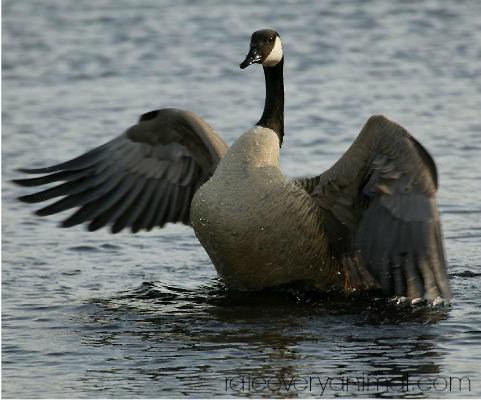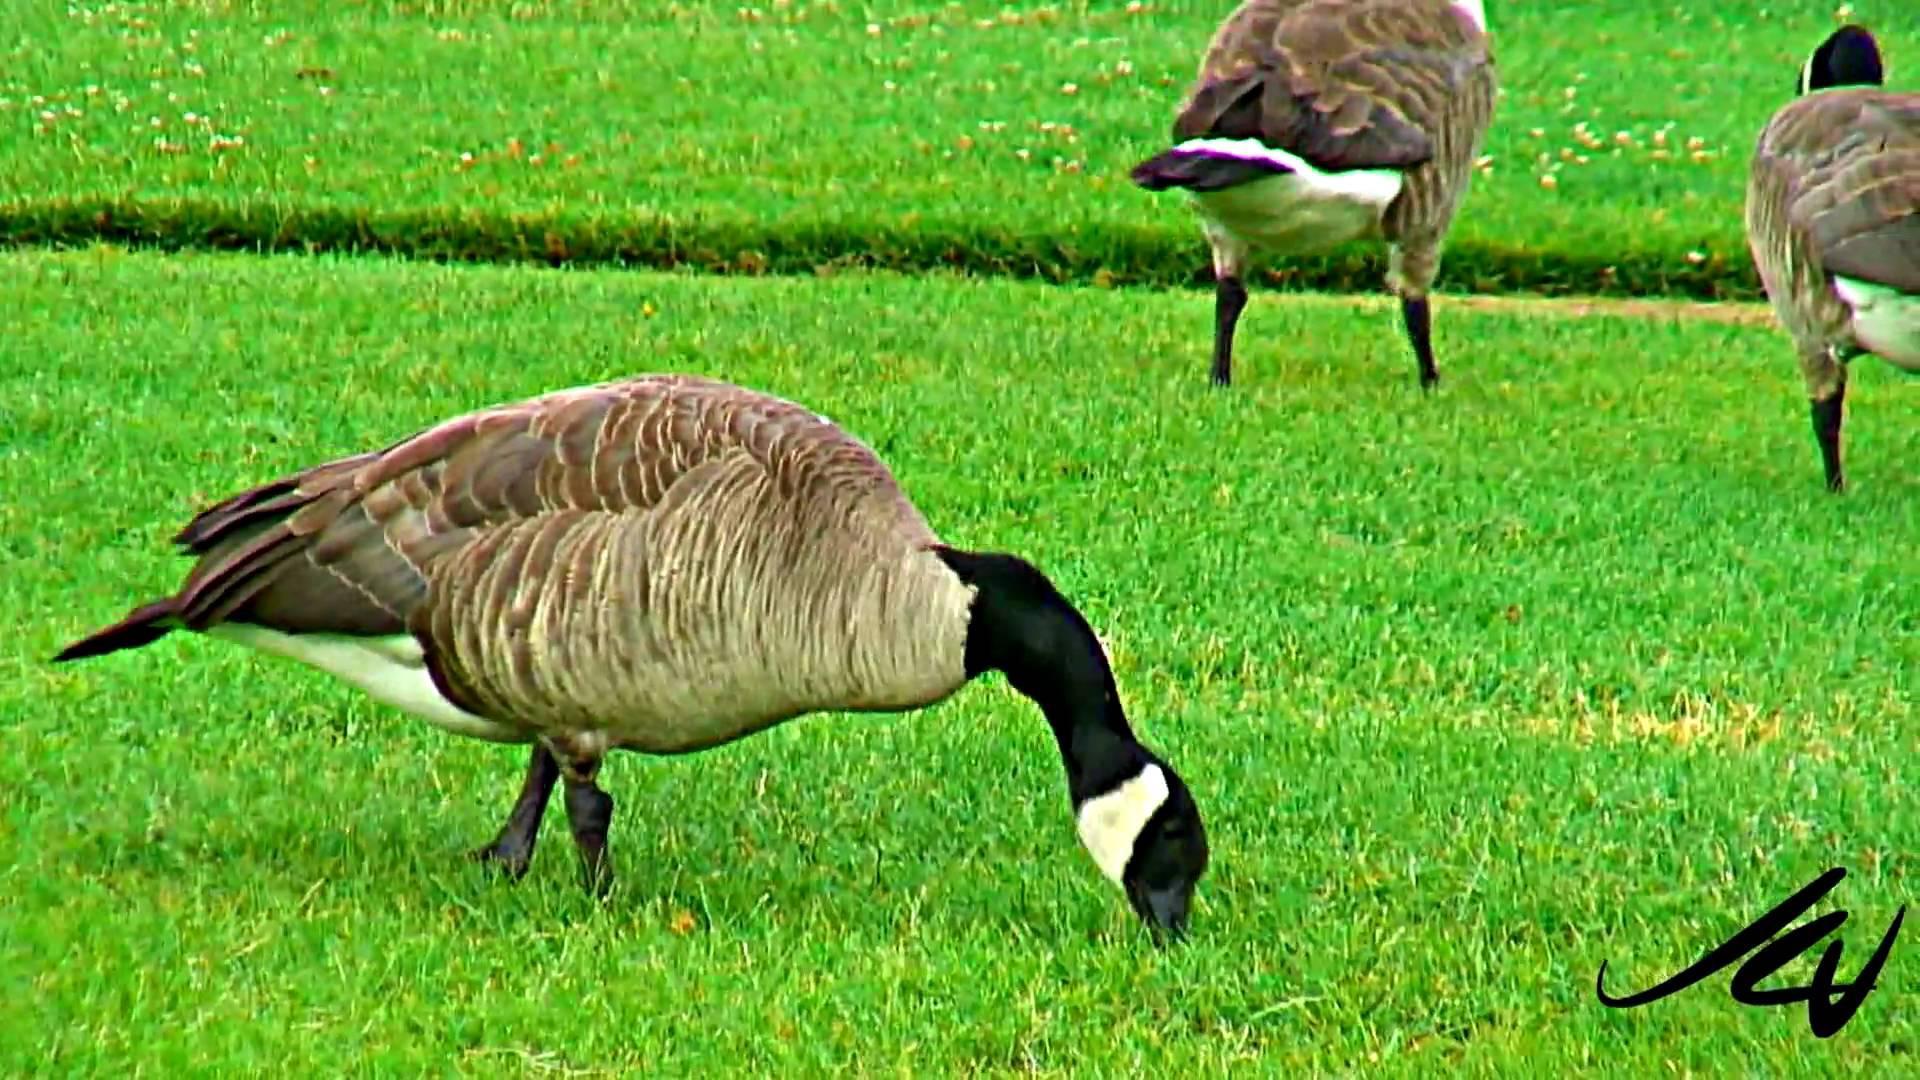The first image is the image on the left, the second image is the image on the right. Evaluate the accuracy of this statement regarding the images: "The left image shows fowl standing on grass.". Is it true? Answer yes or no. No. 